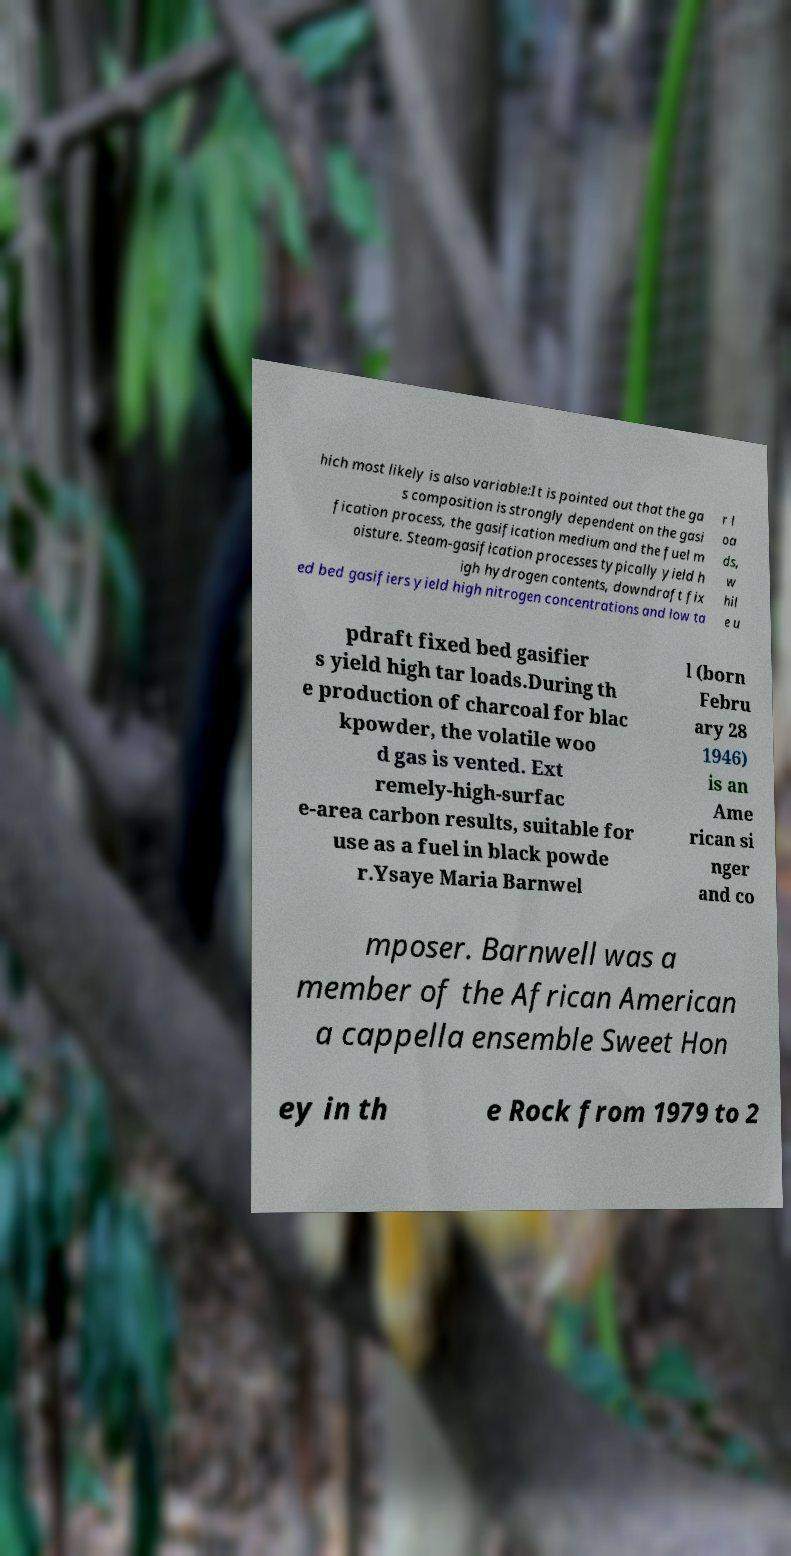Could you extract and type out the text from this image? hich most likely is also variable:It is pointed out that the ga s composition is strongly dependent on the gasi fication process, the gasification medium and the fuel m oisture. Steam-gasification processes typically yield h igh hydrogen contents, downdraft fix ed bed gasifiers yield high nitrogen concentrations and low ta r l oa ds, w hil e u pdraft fixed bed gasifier s yield high tar loads.During th e production of charcoal for blac kpowder, the volatile woo d gas is vented. Ext remely-high-surfac e-area carbon results, suitable for use as a fuel in black powde r.Ysaye Maria Barnwel l (born Febru ary 28 1946) is an Ame rican si nger and co mposer. Barnwell was a member of the African American a cappella ensemble Sweet Hon ey in th e Rock from 1979 to 2 